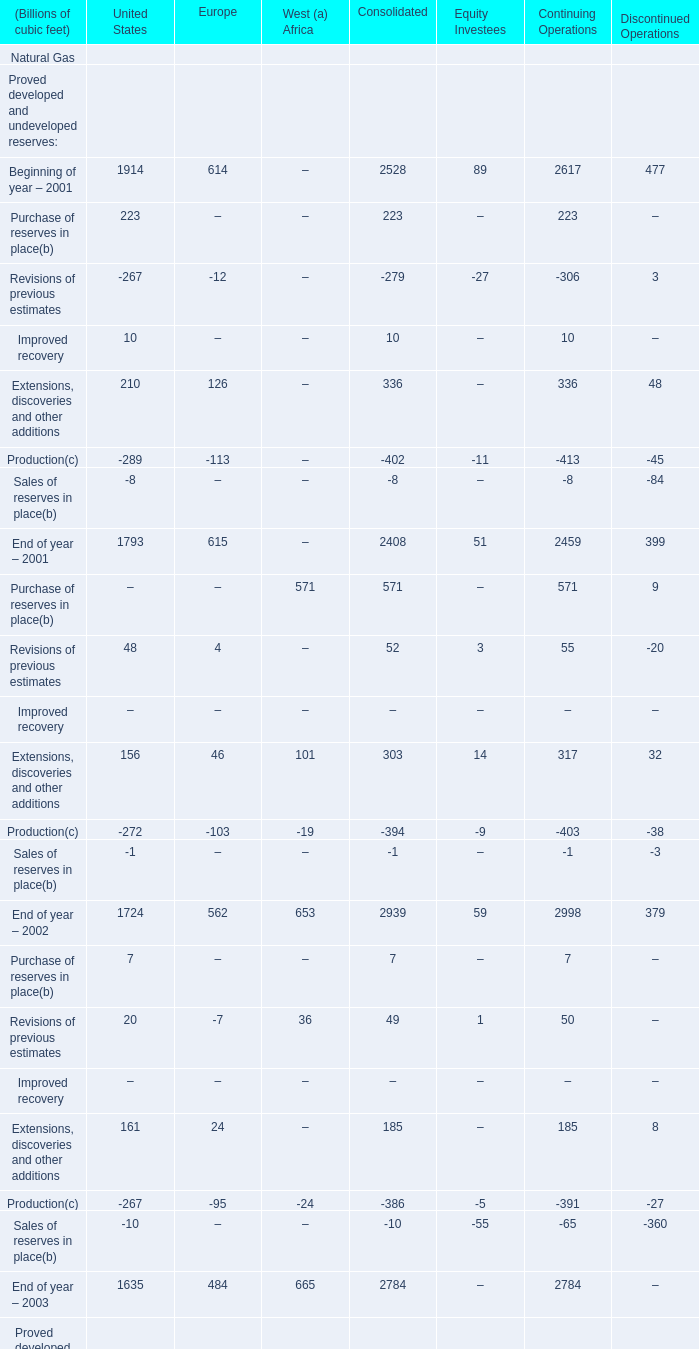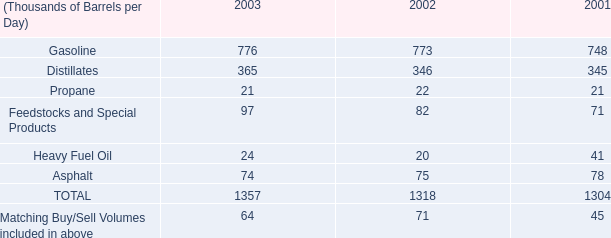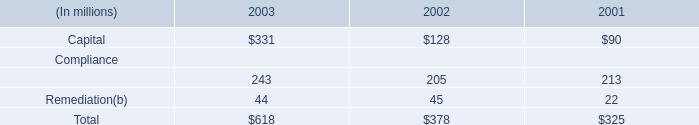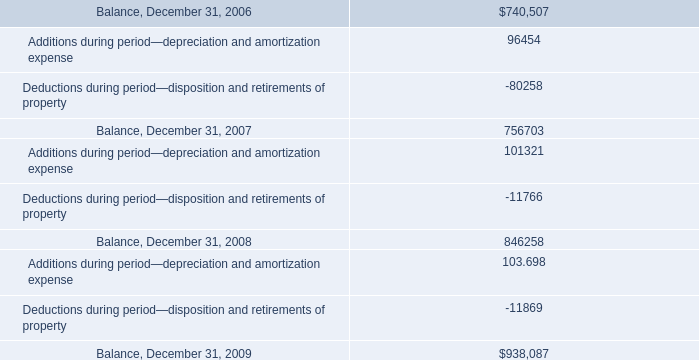What's the average of End of year – 2001 of Continuing Operations, and Balance, December 31, 2009 ? 
Computations: ((2459.0 + 938087.0) / 2)
Answer: 470273.0. 